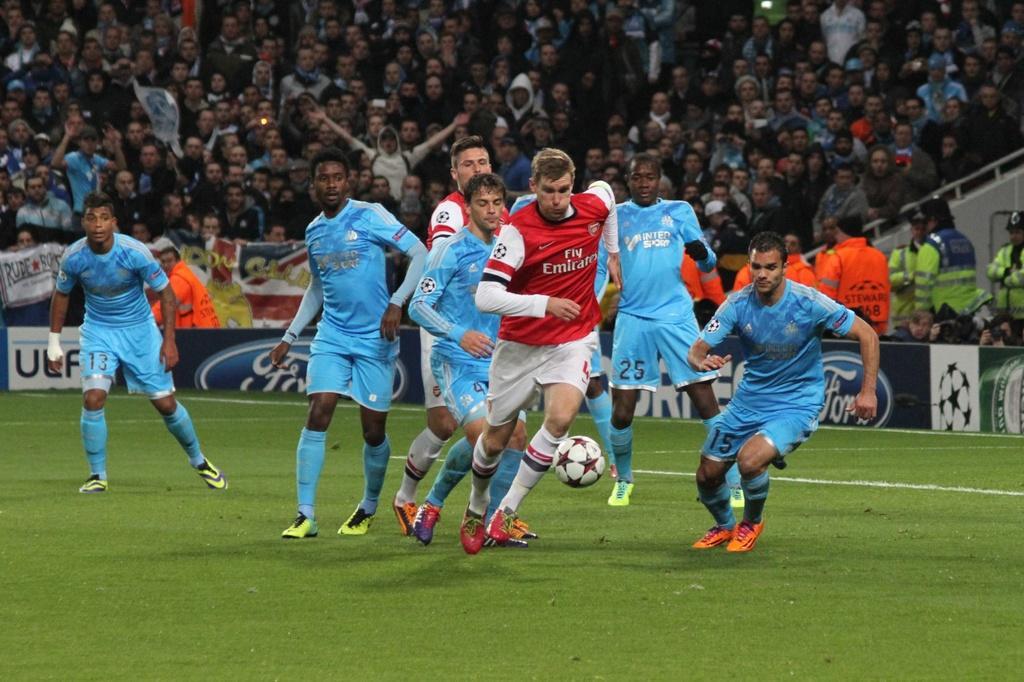Can you describe this image briefly? In this image I can see a ground and few people on it. Here I can see a football and in the background I can see number of people are standing. 